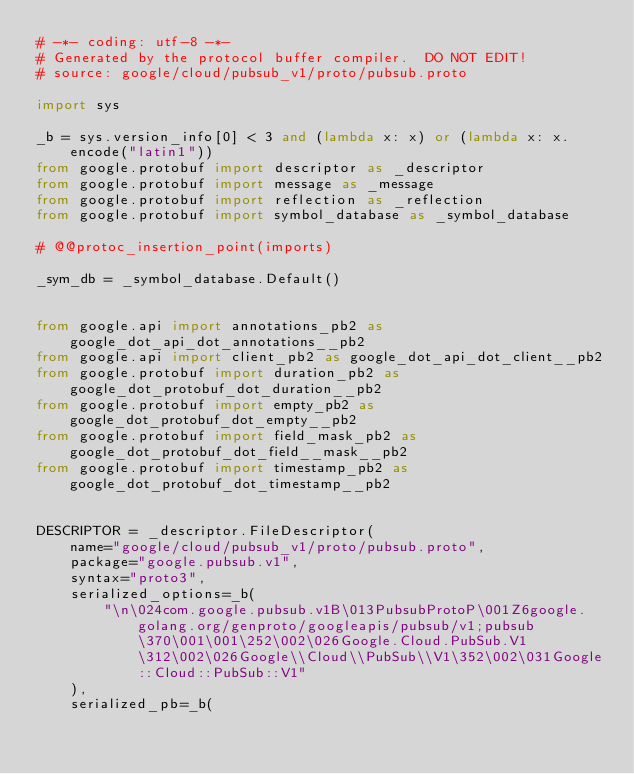Convert code to text. <code><loc_0><loc_0><loc_500><loc_500><_Python_># -*- coding: utf-8 -*-
# Generated by the protocol buffer compiler.  DO NOT EDIT!
# source: google/cloud/pubsub_v1/proto/pubsub.proto

import sys

_b = sys.version_info[0] < 3 and (lambda x: x) or (lambda x: x.encode("latin1"))
from google.protobuf import descriptor as _descriptor
from google.protobuf import message as _message
from google.protobuf import reflection as _reflection
from google.protobuf import symbol_database as _symbol_database

# @@protoc_insertion_point(imports)

_sym_db = _symbol_database.Default()


from google.api import annotations_pb2 as google_dot_api_dot_annotations__pb2
from google.api import client_pb2 as google_dot_api_dot_client__pb2
from google.protobuf import duration_pb2 as google_dot_protobuf_dot_duration__pb2
from google.protobuf import empty_pb2 as google_dot_protobuf_dot_empty__pb2
from google.protobuf import field_mask_pb2 as google_dot_protobuf_dot_field__mask__pb2
from google.protobuf import timestamp_pb2 as google_dot_protobuf_dot_timestamp__pb2


DESCRIPTOR = _descriptor.FileDescriptor(
    name="google/cloud/pubsub_v1/proto/pubsub.proto",
    package="google.pubsub.v1",
    syntax="proto3",
    serialized_options=_b(
        "\n\024com.google.pubsub.v1B\013PubsubProtoP\001Z6google.golang.org/genproto/googleapis/pubsub/v1;pubsub\370\001\001\252\002\026Google.Cloud.PubSub.V1\312\002\026Google\\Cloud\\PubSub\\V1\352\002\031Google::Cloud::PubSub::V1"
    ),
    serialized_pb=_b(</code> 